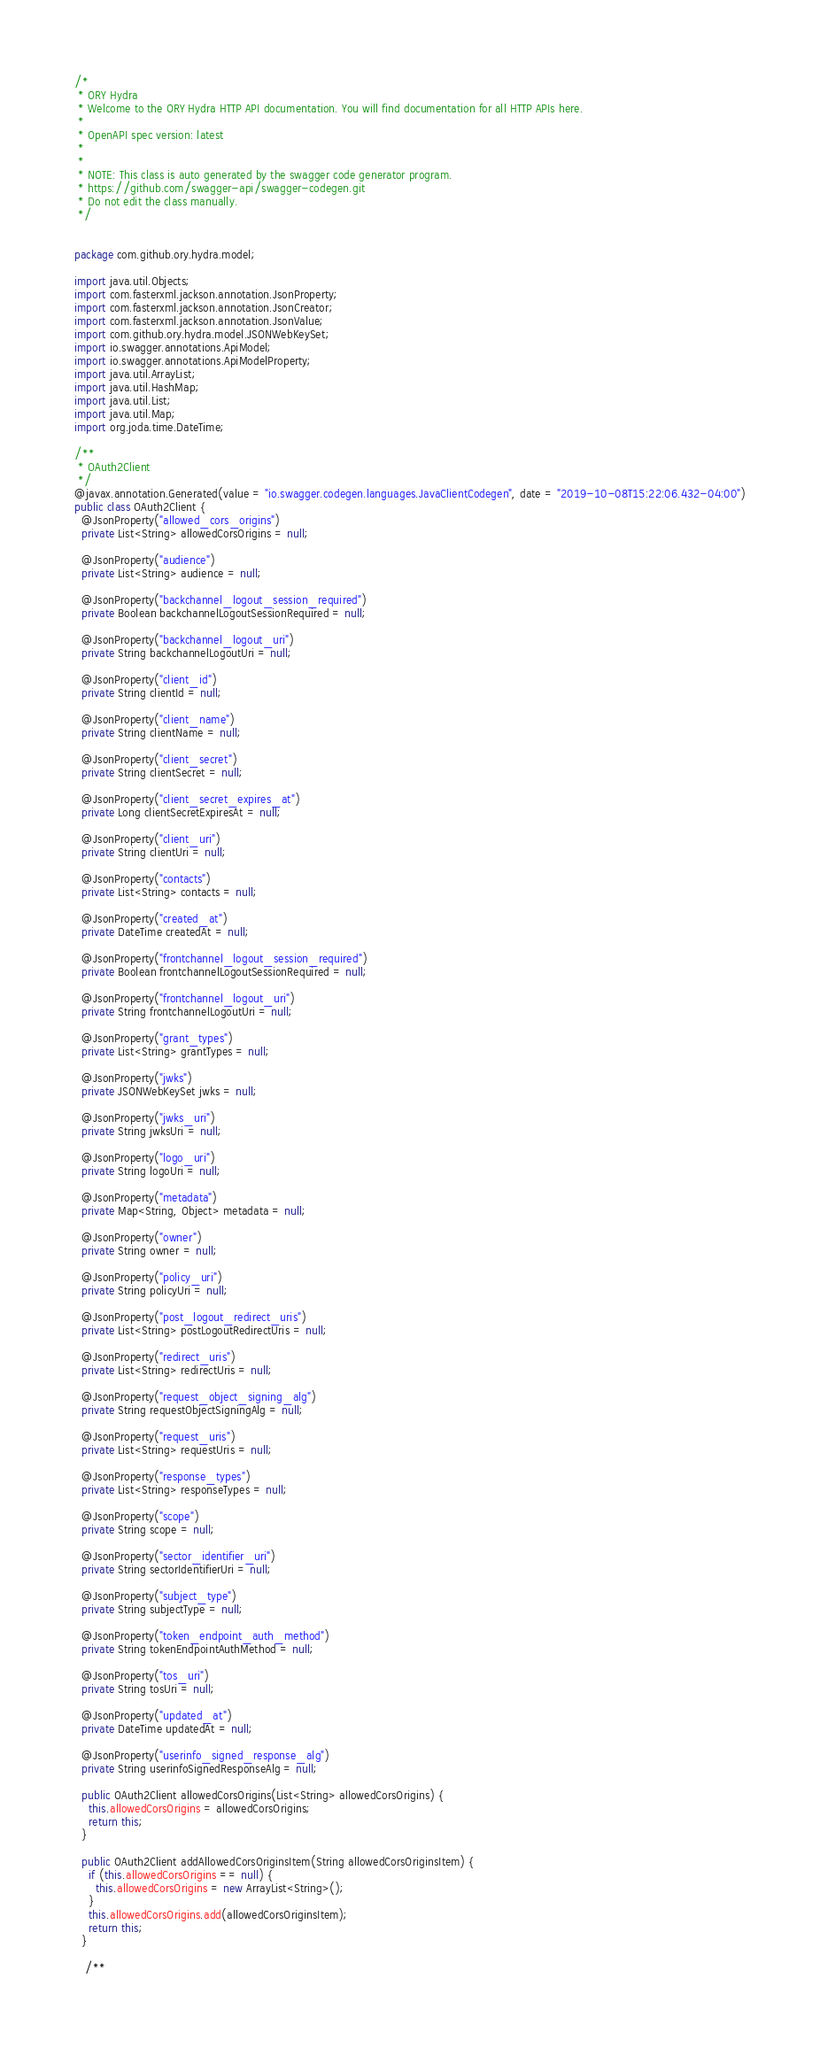<code> <loc_0><loc_0><loc_500><loc_500><_Java_>/*
 * ORY Hydra
 * Welcome to the ORY Hydra HTTP API documentation. You will find documentation for all HTTP APIs here.
 *
 * OpenAPI spec version: latest
 * 
 *
 * NOTE: This class is auto generated by the swagger code generator program.
 * https://github.com/swagger-api/swagger-codegen.git
 * Do not edit the class manually.
 */


package com.github.ory.hydra.model;

import java.util.Objects;
import com.fasterxml.jackson.annotation.JsonProperty;
import com.fasterxml.jackson.annotation.JsonCreator;
import com.fasterxml.jackson.annotation.JsonValue;
import com.github.ory.hydra.model.JSONWebKeySet;
import io.swagger.annotations.ApiModel;
import io.swagger.annotations.ApiModelProperty;
import java.util.ArrayList;
import java.util.HashMap;
import java.util.List;
import java.util.Map;
import org.joda.time.DateTime;

/**
 * OAuth2Client
 */
@javax.annotation.Generated(value = "io.swagger.codegen.languages.JavaClientCodegen", date = "2019-10-08T15:22:06.432-04:00")
public class OAuth2Client {
  @JsonProperty("allowed_cors_origins")
  private List<String> allowedCorsOrigins = null;

  @JsonProperty("audience")
  private List<String> audience = null;

  @JsonProperty("backchannel_logout_session_required")
  private Boolean backchannelLogoutSessionRequired = null;

  @JsonProperty("backchannel_logout_uri")
  private String backchannelLogoutUri = null;

  @JsonProperty("client_id")
  private String clientId = null;

  @JsonProperty("client_name")
  private String clientName = null;

  @JsonProperty("client_secret")
  private String clientSecret = null;

  @JsonProperty("client_secret_expires_at")
  private Long clientSecretExpiresAt = null;

  @JsonProperty("client_uri")
  private String clientUri = null;

  @JsonProperty("contacts")
  private List<String> contacts = null;

  @JsonProperty("created_at")
  private DateTime createdAt = null;

  @JsonProperty("frontchannel_logout_session_required")
  private Boolean frontchannelLogoutSessionRequired = null;

  @JsonProperty("frontchannel_logout_uri")
  private String frontchannelLogoutUri = null;

  @JsonProperty("grant_types")
  private List<String> grantTypes = null;

  @JsonProperty("jwks")
  private JSONWebKeySet jwks = null;

  @JsonProperty("jwks_uri")
  private String jwksUri = null;

  @JsonProperty("logo_uri")
  private String logoUri = null;

  @JsonProperty("metadata")
  private Map<String, Object> metadata = null;

  @JsonProperty("owner")
  private String owner = null;

  @JsonProperty("policy_uri")
  private String policyUri = null;

  @JsonProperty("post_logout_redirect_uris")
  private List<String> postLogoutRedirectUris = null;

  @JsonProperty("redirect_uris")
  private List<String> redirectUris = null;

  @JsonProperty("request_object_signing_alg")
  private String requestObjectSigningAlg = null;

  @JsonProperty("request_uris")
  private List<String> requestUris = null;

  @JsonProperty("response_types")
  private List<String> responseTypes = null;

  @JsonProperty("scope")
  private String scope = null;

  @JsonProperty("sector_identifier_uri")
  private String sectorIdentifierUri = null;

  @JsonProperty("subject_type")
  private String subjectType = null;

  @JsonProperty("token_endpoint_auth_method")
  private String tokenEndpointAuthMethod = null;

  @JsonProperty("tos_uri")
  private String tosUri = null;

  @JsonProperty("updated_at")
  private DateTime updatedAt = null;

  @JsonProperty("userinfo_signed_response_alg")
  private String userinfoSignedResponseAlg = null;

  public OAuth2Client allowedCorsOrigins(List<String> allowedCorsOrigins) {
    this.allowedCorsOrigins = allowedCorsOrigins;
    return this;
  }

  public OAuth2Client addAllowedCorsOriginsItem(String allowedCorsOriginsItem) {
    if (this.allowedCorsOrigins == null) {
      this.allowedCorsOrigins = new ArrayList<String>();
    }
    this.allowedCorsOrigins.add(allowedCorsOriginsItem);
    return this;
  }

   /**</code> 